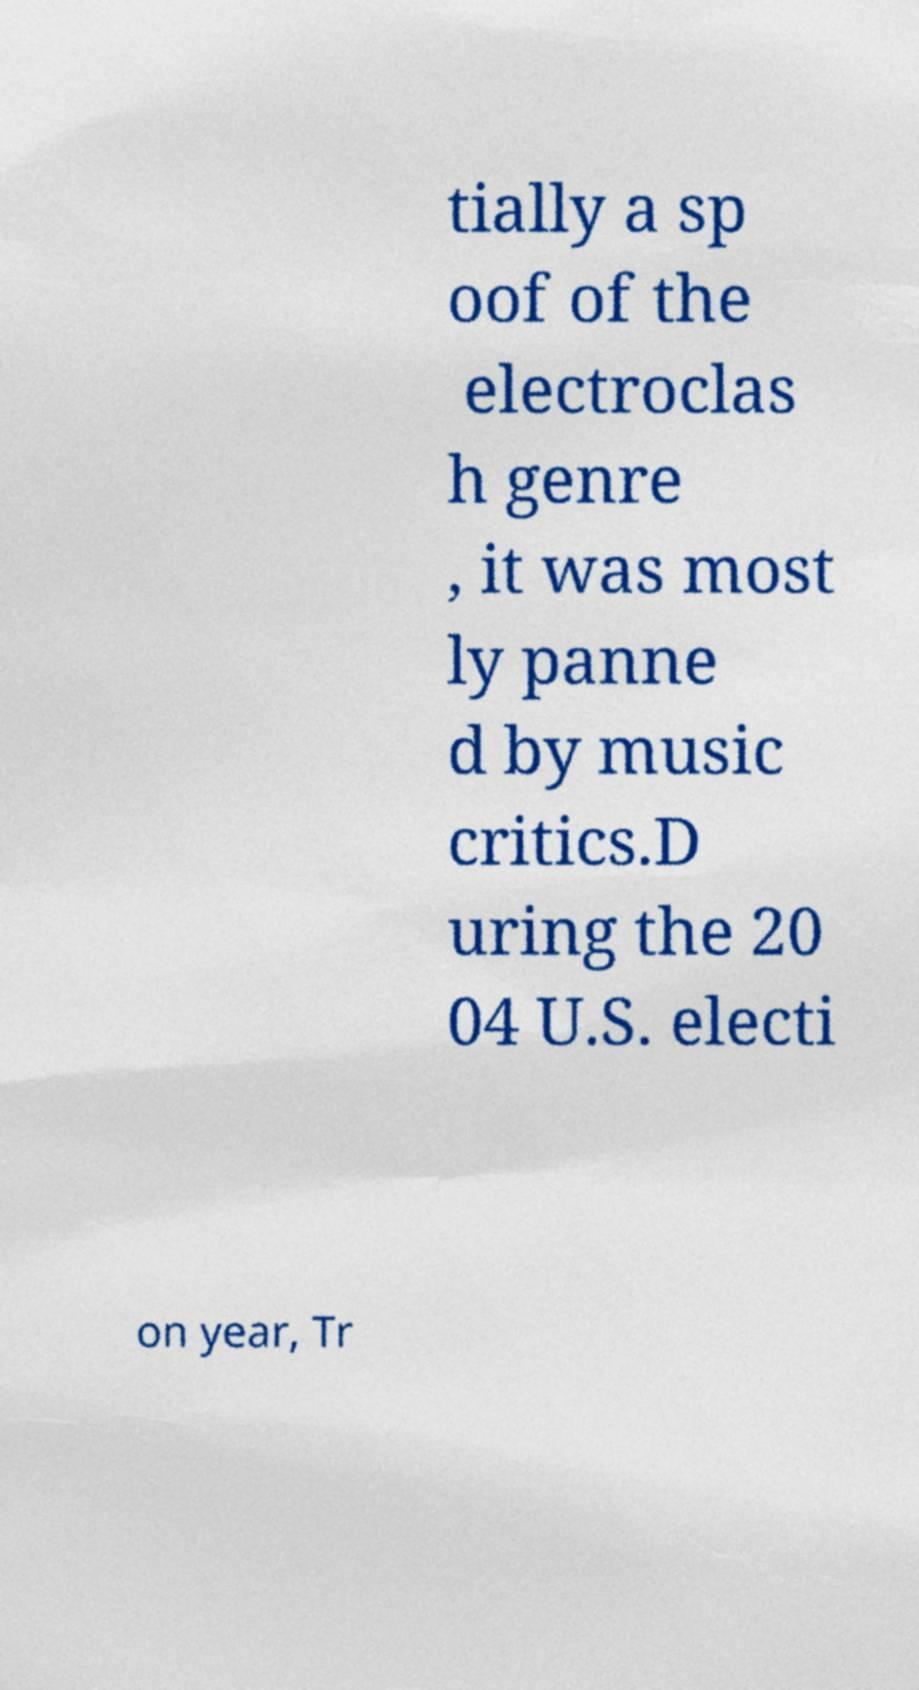There's text embedded in this image that I need extracted. Can you transcribe it verbatim? tially a sp oof of the electroclas h genre , it was most ly panne d by music critics.D uring the 20 04 U.S. electi on year, Tr 